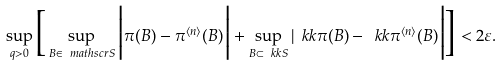<formula> <loc_0><loc_0><loc_500><loc_500>\sup _ { q > 0 } \Big [ \sup _ { B \in \ m a t h s c r { S } } \Big | \pi ( B ) - \pi ^ { \langle n \rangle } ( B ) \Big | + \sup _ { B \subset \ k k { S } } | \ k k { \pi } ( B ) - \ k k { \pi } ^ { \langle n \rangle } ( B ) \Big | \Big ] < 2 \varepsilon .</formula> 